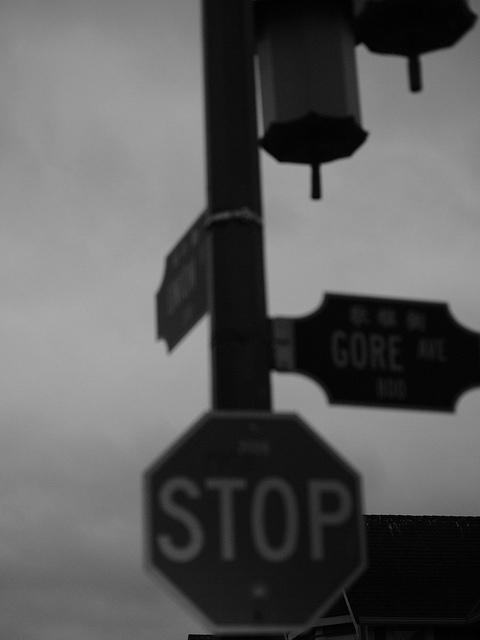How many stop signs are there?
Give a very brief answer. 1. How many plates have a sandwich on it?
Give a very brief answer. 0. 